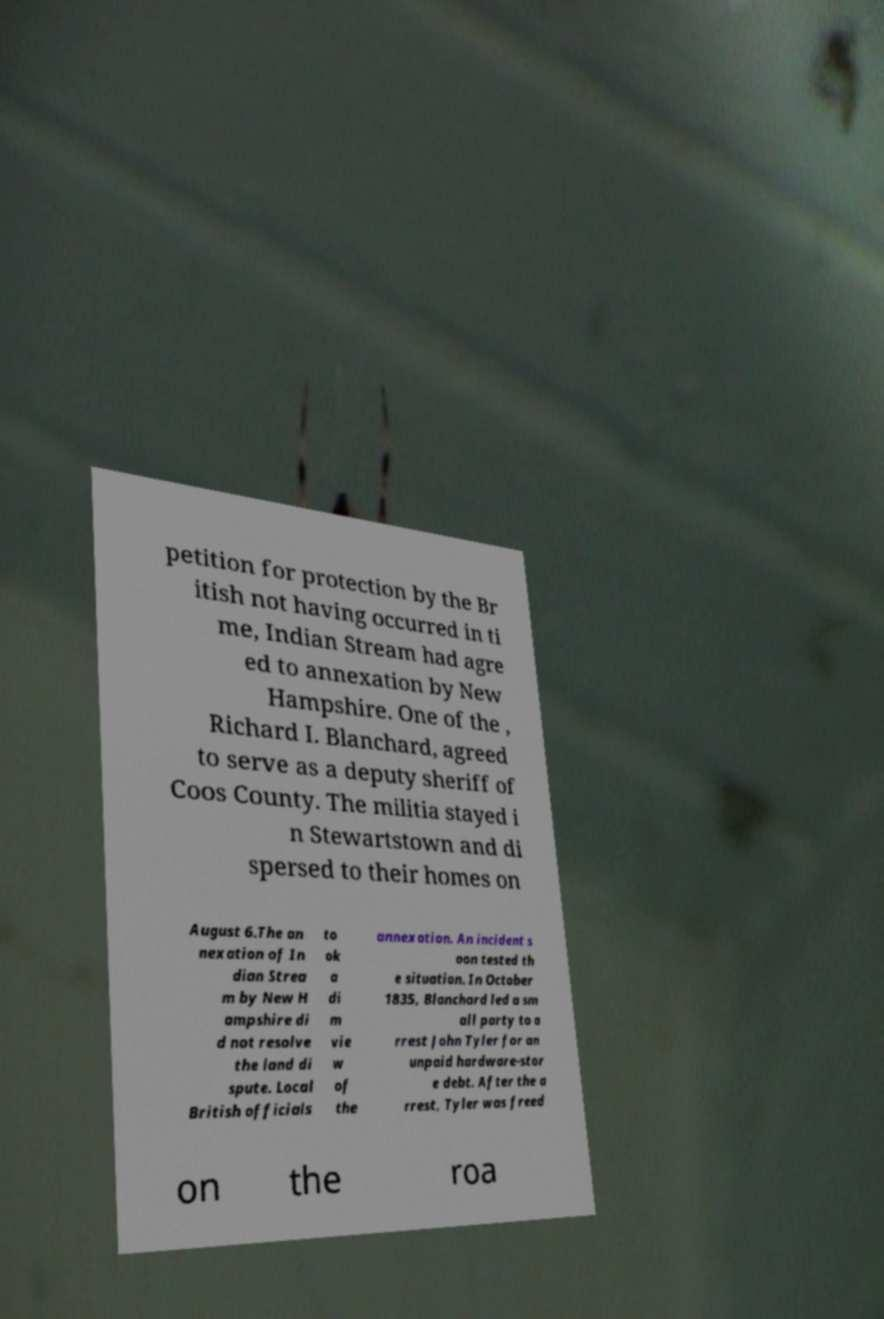For documentation purposes, I need the text within this image transcribed. Could you provide that? petition for protection by the Br itish not having occurred in ti me, Indian Stream had agre ed to annexation by New Hampshire. One of the , Richard I. Blanchard, agreed to serve as a deputy sheriff of Coos County. The militia stayed i n Stewartstown and di spersed to their homes on August 6.The an nexation of In dian Strea m by New H ampshire di d not resolve the land di spute. Local British officials to ok a di m vie w of the annexation. An incident s oon tested th e situation. In October 1835, Blanchard led a sm all party to a rrest John Tyler for an unpaid hardware-stor e debt. After the a rrest, Tyler was freed on the roa 